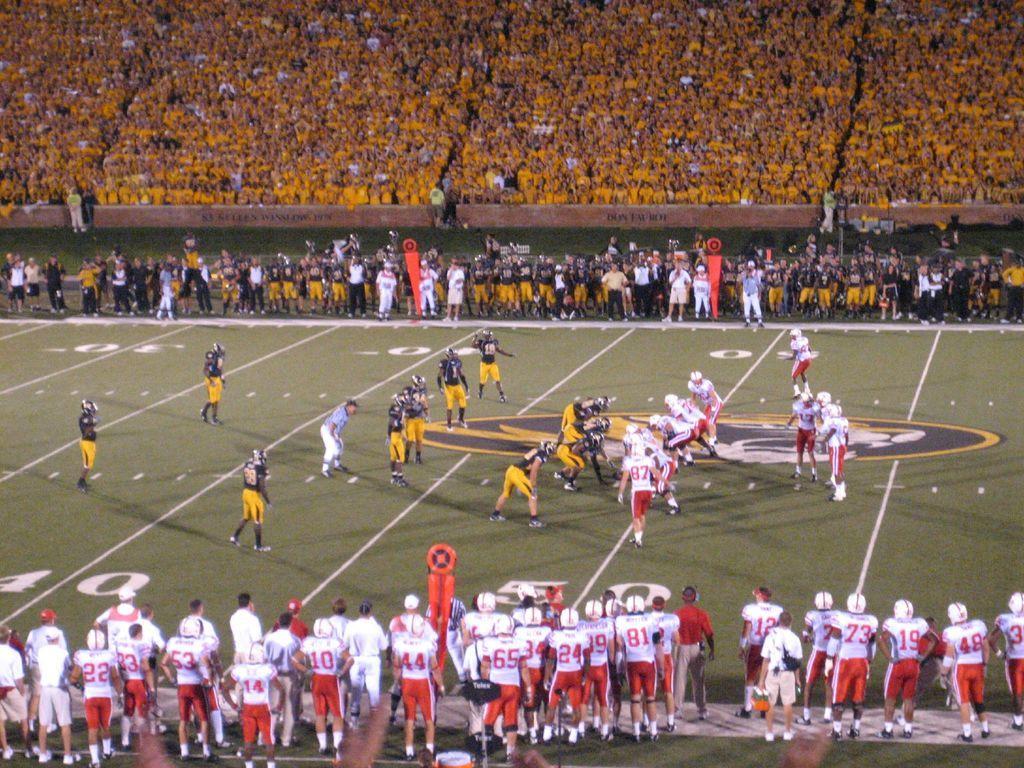Please provide a concise description of this image. This image is taken in a stadium. At the bottom of the image there is a ground with grass on it and many people are standing on the ground. In the middle of the image as few men are playing rugby in the ground. At the top of the image there are many people sitting on the chairs and there is a board with a text on it. Many people are standing on the ground. 